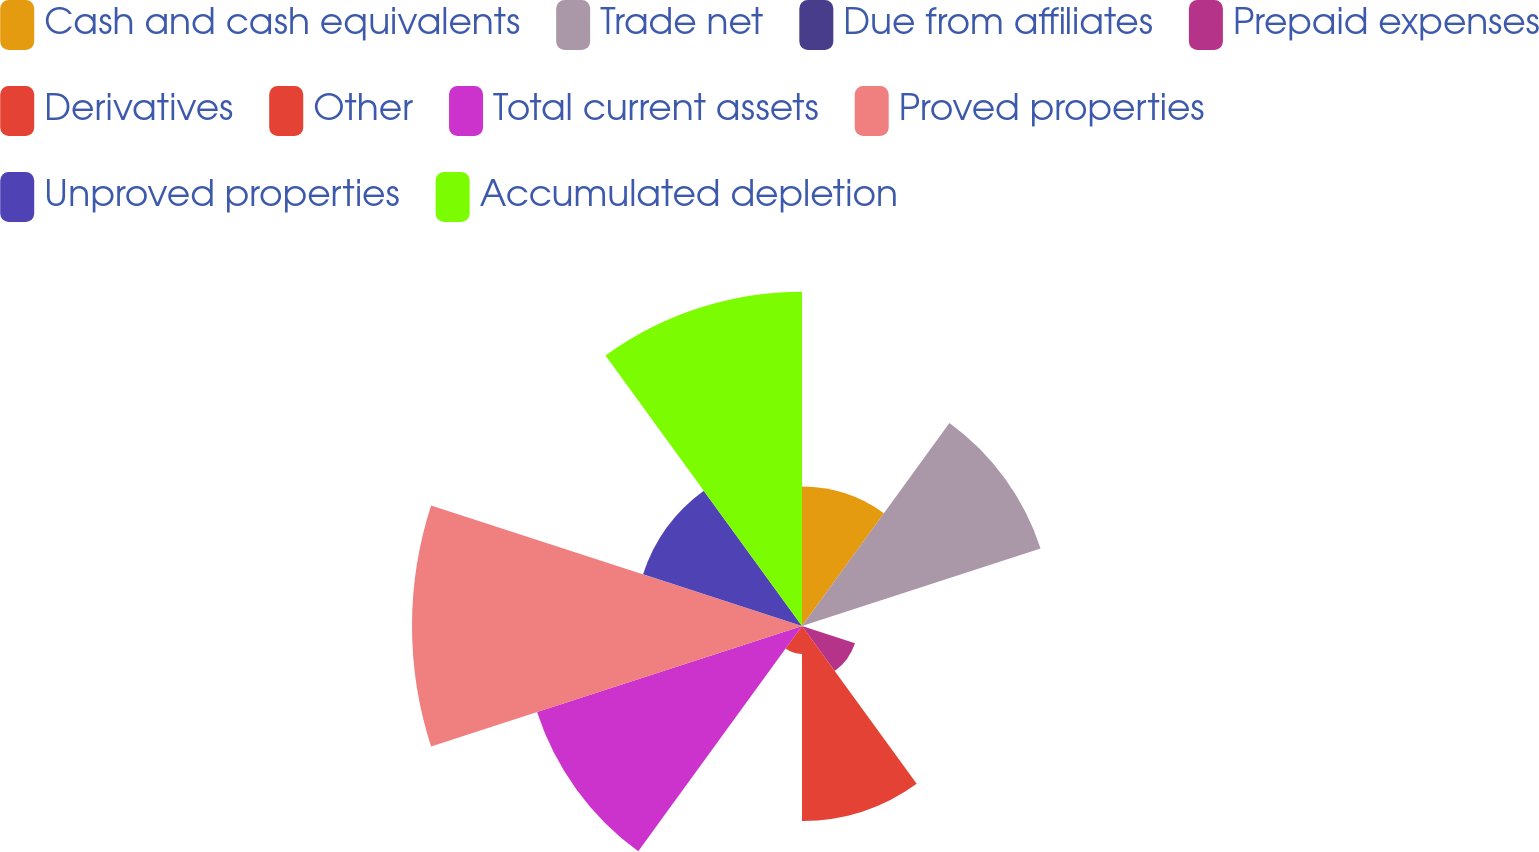<chart> <loc_0><loc_0><loc_500><loc_500><pie_chart><fcel>Cash and cash equivalents<fcel>Trade net<fcel>Due from affiliates<fcel>Prepaid expenses<fcel>Derivatives<fcel>Other<fcel>Total current assets<fcel>Proved properties<fcel>Unproved properties<fcel>Accumulated depletion<nl><fcel>7.58%<fcel>13.64%<fcel>0.0%<fcel>3.03%<fcel>10.61%<fcel>1.52%<fcel>15.15%<fcel>21.21%<fcel>9.09%<fcel>18.18%<nl></chart> 